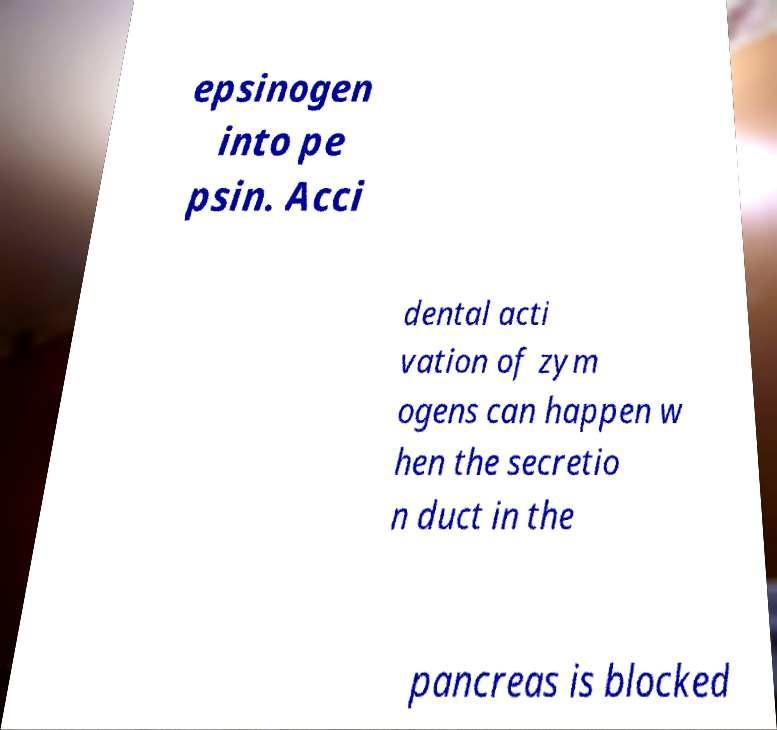I need the written content from this picture converted into text. Can you do that? epsinogen into pe psin. Acci dental acti vation of zym ogens can happen w hen the secretio n duct in the pancreas is blocked 